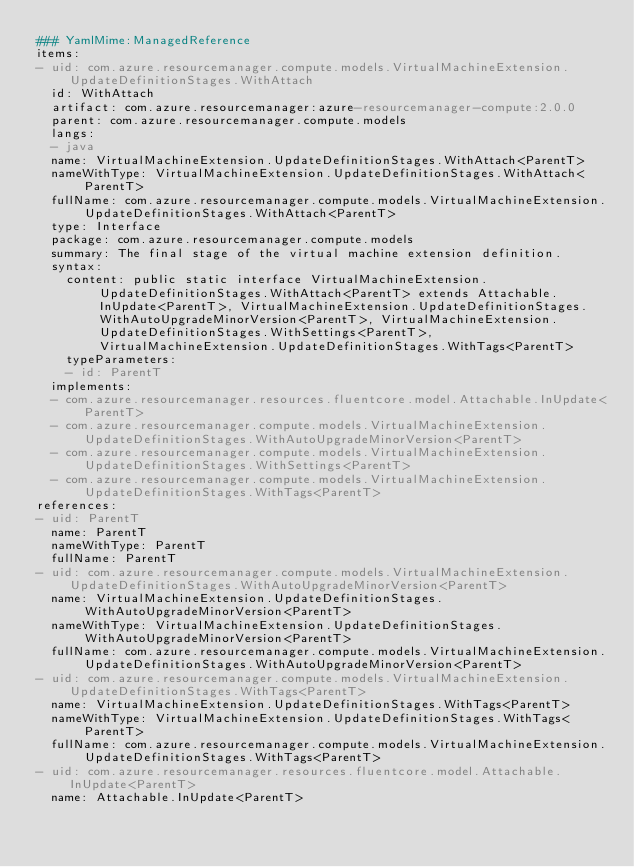<code> <loc_0><loc_0><loc_500><loc_500><_YAML_>### YamlMime:ManagedReference
items:
- uid: com.azure.resourcemanager.compute.models.VirtualMachineExtension.UpdateDefinitionStages.WithAttach
  id: WithAttach
  artifact: com.azure.resourcemanager:azure-resourcemanager-compute:2.0.0
  parent: com.azure.resourcemanager.compute.models
  langs:
  - java
  name: VirtualMachineExtension.UpdateDefinitionStages.WithAttach<ParentT>
  nameWithType: VirtualMachineExtension.UpdateDefinitionStages.WithAttach<ParentT>
  fullName: com.azure.resourcemanager.compute.models.VirtualMachineExtension.UpdateDefinitionStages.WithAttach<ParentT>
  type: Interface
  package: com.azure.resourcemanager.compute.models
  summary: The final stage of the virtual machine extension definition.
  syntax:
    content: public static interface VirtualMachineExtension.UpdateDefinitionStages.WithAttach<ParentT> extends Attachable.InUpdate<ParentT>, VirtualMachineExtension.UpdateDefinitionStages.WithAutoUpgradeMinorVersion<ParentT>, VirtualMachineExtension.UpdateDefinitionStages.WithSettings<ParentT>, VirtualMachineExtension.UpdateDefinitionStages.WithTags<ParentT>
    typeParameters:
    - id: ParentT
  implements:
  - com.azure.resourcemanager.resources.fluentcore.model.Attachable.InUpdate<ParentT>
  - com.azure.resourcemanager.compute.models.VirtualMachineExtension.UpdateDefinitionStages.WithAutoUpgradeMinorVersion<ParentT>
  - com.azure.resourcemanager.compute.models.VirtualMachineExtension.UpdateDefinitionStages.WithSettings<ParentT>
  - com.azure.resourcemanager.compute.models.VirtualMachineExtension.UpdateDefinitionStages.WithTags<ParentT>
references:
- uid: ParentT
  name: ParentT
  nameWithType: ParentT
  fullName: ParentT
- uid: com.azure.resourcemanager.compute.models.VirtualMachineExtension.UpdateDefinitionStages.WithAutoUpgradeMinorVersion<ParentT>
  name: VirtualMachineExtension.UpdateDefinitionStages.WithAutoUpgradeMinorVersion<ParentT>
  nameWithType: VirtualMachineExtension.UpdateDefinitionStages.WithAutoUpgradeMinorVersion<ParentT>
  fullName: com.azure.resourcemanager.compute.models.VirtualMachineExtension.UpdateDefinitionStages.WithAutoUpgradeMinorVersion<ParentT>
- uid: com.azure.resourcemanager.compute.models.VirtualMachineExtension.UpdateDefinitionStages.WithTags<ParentT>
  name: VirtualMachineExtension.UpdateDefinitionStages.WithTags<ParentT>
  nameWithType: VirtualMachineExtension.UpdateDefinitionStages.WithTags<ParentT>
  fullName: com.azure.resourcemanager.compute.models.VirtualMachineExtension.UpdateDefinitionStages.WithTags<ParentT>
- uid: com.azure.resourcemanager.resources.fluentcore.model.Attachable.InUpdate<ParentT>
  name: Attachable.InUpdate<ParentT></code> 